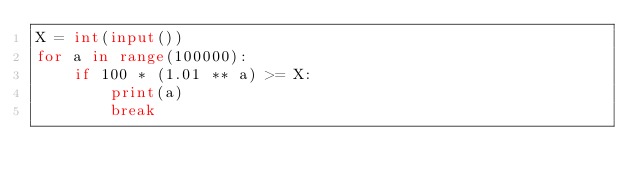Convert code to text. <code><loc_0><loc_0><loc_500><loc_500><_Python_>X = int(input())
for a in range(100000):
    if 100 * (1.01 ** a) >= X:
        print(a)
        break</code> 